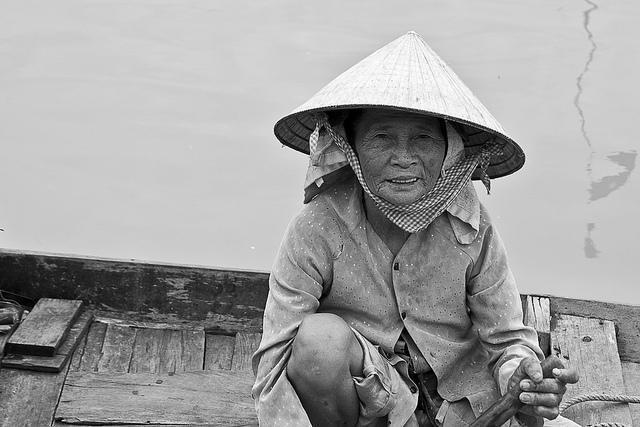How many boys are shown?
Give a very brief answer. 0. 